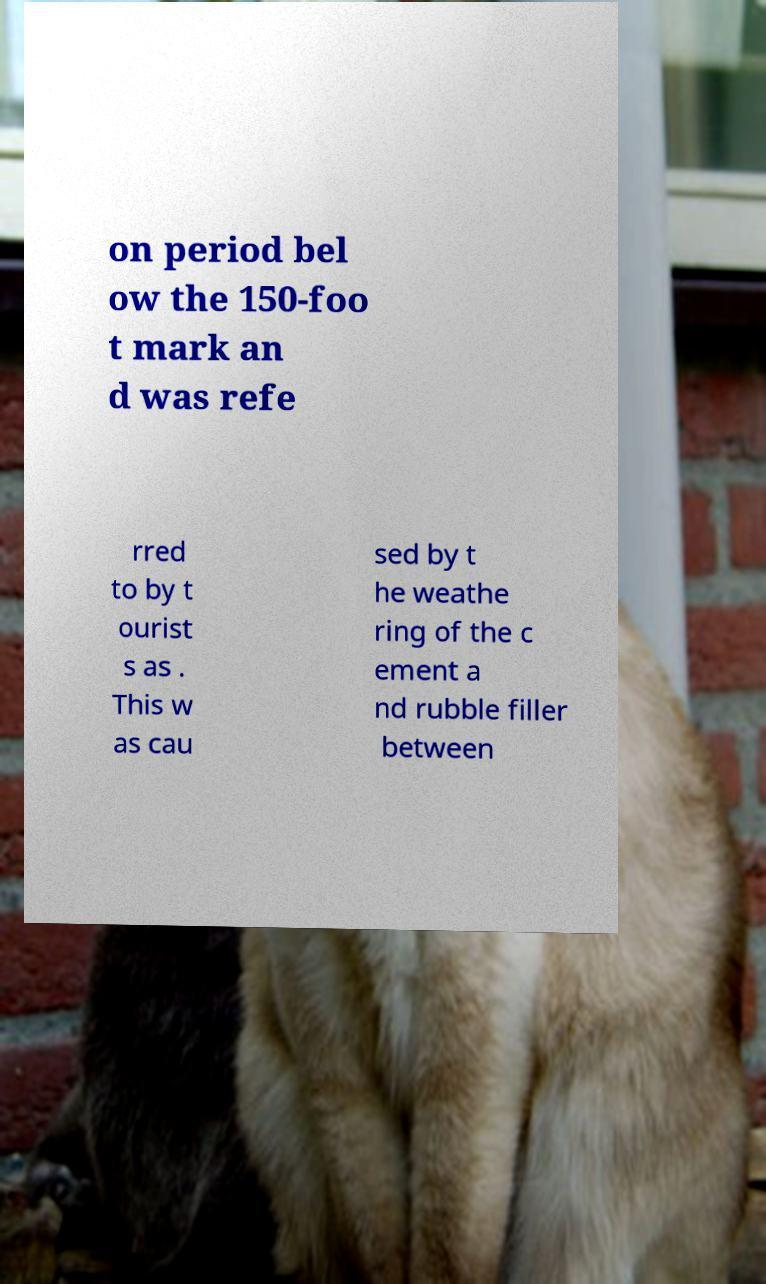Could you assist in decoding the text presented in this image and type it out clearly? on period bel ow the 150-foo t mark an d was refe rred to by t ourist s as . This w as cau sed by t he weathe ring of the c ement a nd rubble filler between 